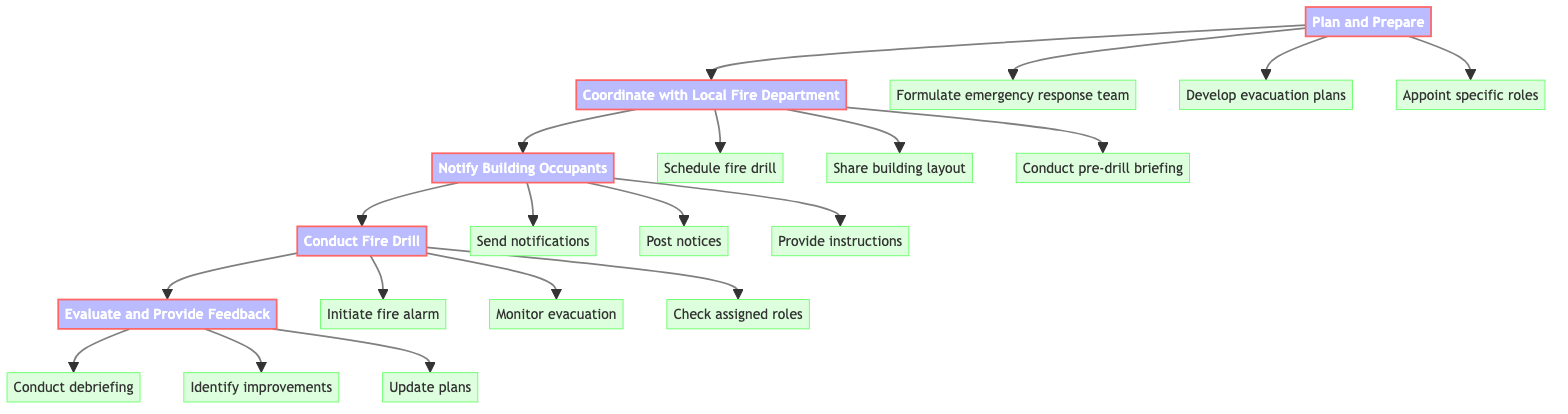What is the first step in conducting a successful fire drill? The diagram shows that the first step is "Plan and Prepare." This is indicated as the starting point of the flow chart, leading to the next step.
Answer: Plan and Prepare How many main steps are there in the flow chart? By counting the main nodes in the flow chart, there are five main steps: Plan and Prepare, Coordinate with Local Fire Department, Notify Building Occupants, Conduct Fire Drill, and Evaluate and Provide Feedback.
Answer: Five What action is part of the "Evaluate and Provide Feedback" step? The diagram specifies multiple actions under "Evaluate and Provide Feedback," and one of them is "Conduct debriefing." This can be directly inferred from the actions listed under that step.
Answer: Conduct debriefing Which step follows "Notify Building Occupants"? From the flow chart, "Conduct Fire Drill" directly follows "Notify Building Occupants." The arrows indicate the flow direction, leading to the next step in the process.
Answer: Conduct Fire Drill What is the last action in the sequence of steps shown in the diagram? The final step in the flow chart is "Evaluate and Provide Feedback," with the last action listed under it being "Update plans." This indicates the process concludes here after the evaluation.
Answer: Update plans What specific role is appointed in the "Plan and Prepare" step? Under the "Plan and Prepare" step, a specific role that can be appointed is "floor wardens," which is mentioned as one of the actions. This highlights the importance of assigned roles.
Answer: Floor wardens Which step includes coordinating with local fire department? The step titled "Coordinate with Local Fire Department" includes all actions related to communication and planning with firefighting authorities. This step explicitly addresses this coordination.
Answer: Coordinate with Local Fire Department How many actions are listed under the "Conduct Fire Drill" step? There are three actions listed under the "Conduct Fire Drill" step: "Initiate fire alarm," "Monitor evacuation," and "Check assigned roles." By counting them, we find that there are three distinct actions.
Answer: Three 